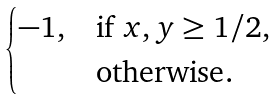<formula> <loc_0><loc_0><loc_500><loc_500>\begin{cases} - 1 , & \text {if $x,y\geq 1/2$} , \\ & \text {otherwise} . \end{cases}</formula> 